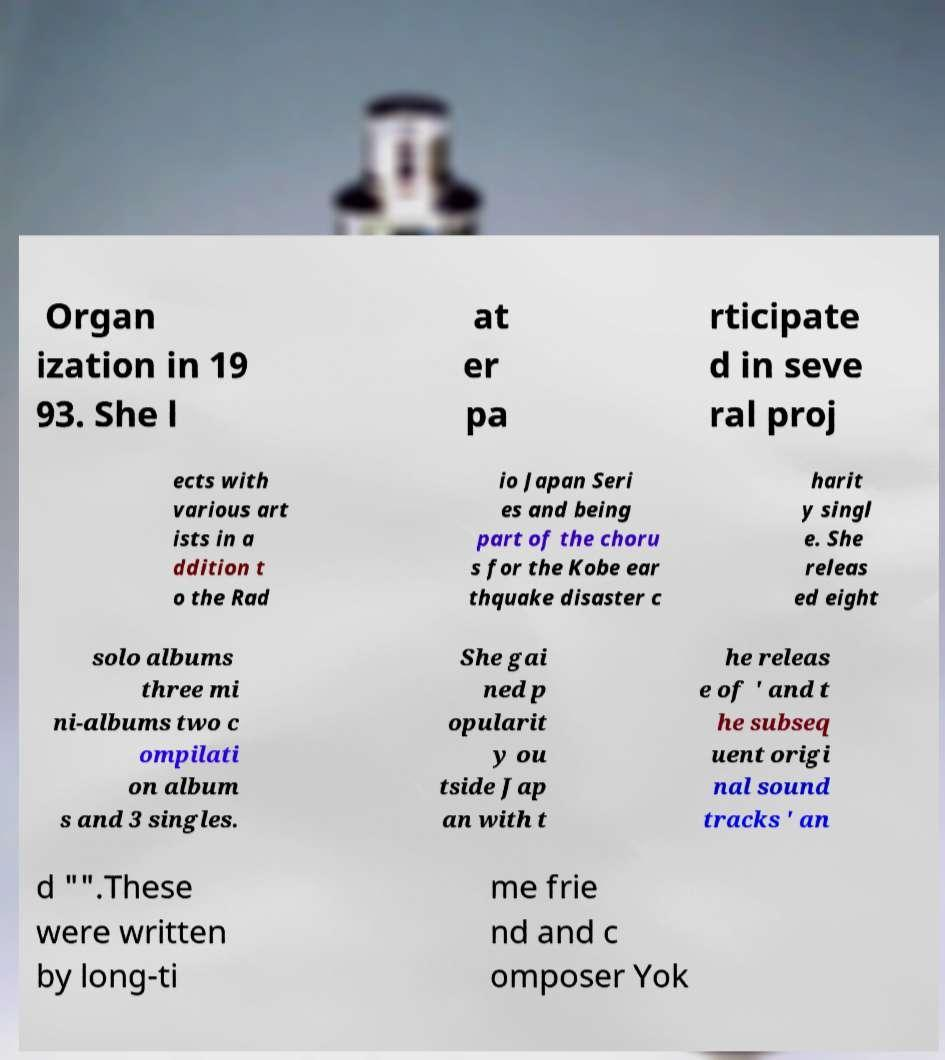Can you read and provide the text displayed in the image?This photo seems to have some interesting text. Can you extract and type it out for me? Organ ization in 19 93. She l at er pa rticipate d in seve ral proj ects with various art ists in a ddition t o the Rad io Japan Seri es and being part of the choru s for the Kobe ear thquake disaster c harit y singl e. She releas ed eight solo albums three mi ni-albums two c ompilati on album s and 3 singles. She gai ned p opularit y ou tside Jap an with t he releas e of ' and t he subseq uent origi nal sound tracks ' an d "".These were written by long-ti me frie nd and c omposer Yok 